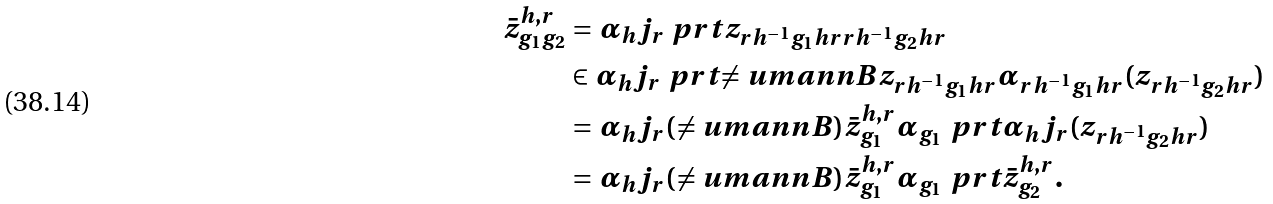<formula> <loc_0><loc_0><loc_500><loc_500>\bar { z } _ { g _ { 1 } g _ { 2 } } ^ { h , r } & = \alpha _ { h } j _ { r } \ p r t { z _ { r h ^ { - 1 } g _ { 1 } h r r h ^ { - 1 } g _ { 2 } h r } } \\ & \in \alpha _ { h } j _ { r } \ p r t { \ne u m a n n B z _ { r h ^ { - 1 } g _ { 1 } h r } \alpha _ { r h ^ { - 1 } g _ { 1 } h r } ( z _ { r h ^ { - 1 } g _ { 2 } h r } ) } \\ & = \alpha _ { h } j _ { r } ( \ne u m a n n B ) \bar { z } _ { g _ { 1 } } ^ { h , r } \alpha _ { g _ { 1 } } \ p r t { \alpha _ { h } j _ { r } ( z _ { r h ^ { - 1 } g _ { 2 } h r } ) } \\ & = \alpha _ { h } j _ { r } ( \ne u m a n n B ) \bar { z } _ { g _ { 1 } } ^ { h , r } \alpha _ { g _ { 1 } } \ p r t { \bar { z } _ { g _ { 2 } } ^ { h , r } } .</formula> 